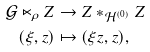Convert formula to latex. <formula><loc_0><loc_0><loc_500><loc_500>\mathcal { G } \ltimes _ { \rho } Z & \rightarrow Z * _ { \mathcal { H } ^ { ( 0 ) } } Z \\ ( \xi , z ) & \mapsto ( \xi z , z ) ,</formula> 